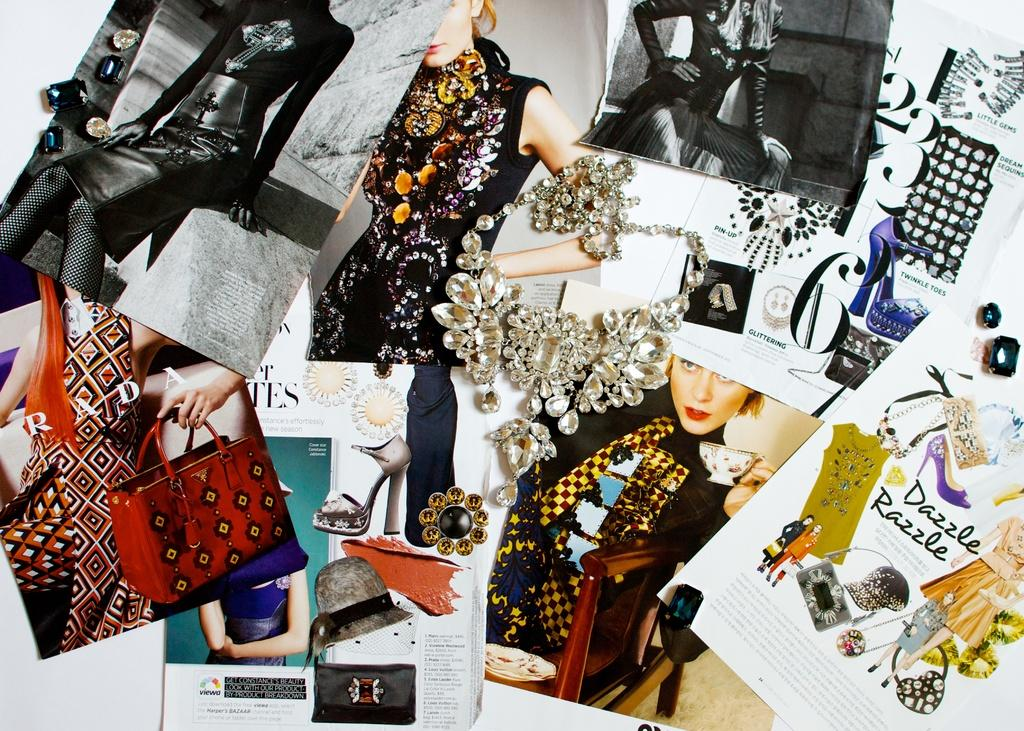What can be seen on the posts in the image? There are posts with images and text in the image. Can you describe any specific details on the posters? There is a necklace on one of the posters. How many suitcases are visible in the image? There are no suitcases present in the image. What type of planes are featured in the images on the posts? There are no planes present in the images on the posts. 